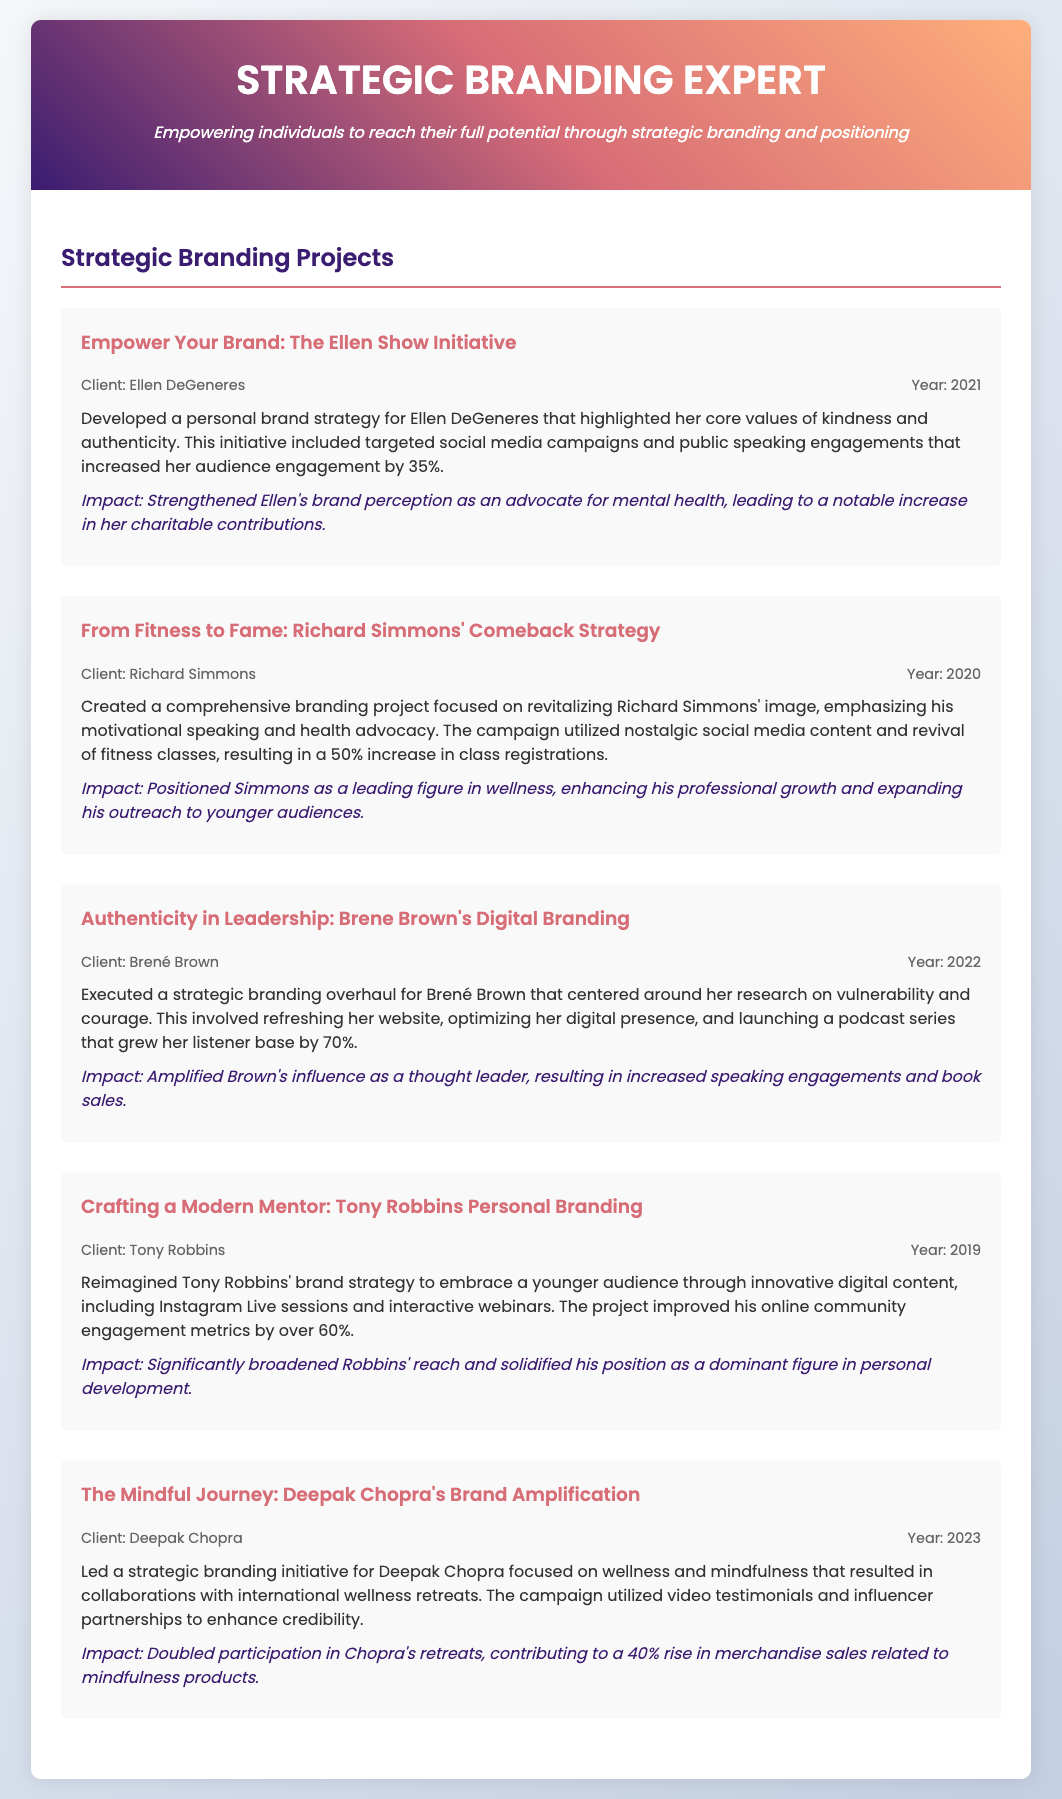What is the title of the CV? The title of the CV is displayed prominently at the top and identifies the professional specialization.
Answer: Strategic Branding Expert Who was the client for the 2021 project? The project is described clearly, and the client is mentioned alongside the project title and year.
Answer: Ellen DeGeneres What year did the project for Deepak Chopra take place? The projects are listed chronologically, allowing easy identification of the year for each client.
Answer: 2023 What was the impact of Brené Brown's branding project? Each project includes a description of the impact, demonstrating effectiveness in branding initiatives.
Answer: Increased speaking engagements and book sales Which project had the highest percentage increase in engagement? By comparing the impacts of the projects, one can identify which had the most significant outcome.
Answer: 70% What type of initiatives were included in Richard Simmons' branding strategy? The content discusses specific strategies used in the branding projects, allowing clear identification of types.
Answer: Motivational speaking and health advocacy What was a common theme among the branding strategies? The projects share overarching themes and objectives, which can be inferred from the provided descriptions.
Answer: Authenticity and engagement Which two branding projects were conducted in 2022 and 2023? By listing the projects chronologically, it’s possible to pinpoint the relevant years for each client's initiatives.
Answer: Brené Brown, Deepak Chopra 